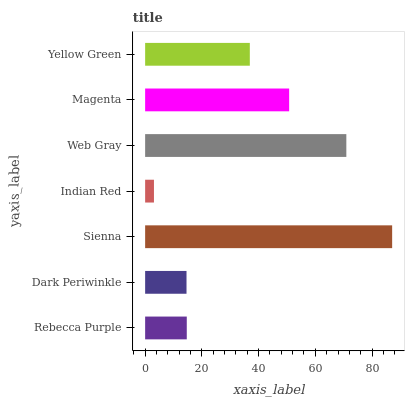Is Indian Red the minimum?
Answer yes or no. Yes. Is Sienna the maximum?
Answer yes or no. Yes. Is Dark Periwinkle the minimum?
Answer yes or no. No. Is Dark Periwinkle the maximum?
Answer yes or no. No. Is Rebecca Purple greater than Dark Periwinkle?
Answer yes or no. Yes. Is Dark Periwinkle less than Rebecca Purple?
Answer yes or no. Yes. Is Dark Periwinkle greater than Rebecca Purple?
Answer yes or no. No. Is Rebecca Purple less than Dark Periwinkle?
Answer yes or no. No. Is Yellow Green the high median?
Answer yes or no. Yes. Is Yellow Green the low median?
Answer yes or no. Yes. Is Magenta the high median?
Answer yes or no. No. Is Rebecca Purple the low median?
Answer yes or no. No. 